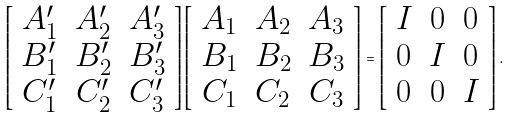<formula> <loc_0><loc_0><loc_500><loc_500>\left [ \begin{array} { c c c } A _ { 1 } ^ { \prime } & A _ { 2 } ^ { \prime } & A _ { 3 } ^ { \prime } \\ B _ { 1 } ^ { \prime } & B _ { 2 } ^ { \prime } & B _ { 3 } ^ { \prime } \\ C _ { 1 } ^ { \prime } & C _ { 2 } ^ { \prime } & C _ { 3 } ^ { \prime } \\ \end{array} \right ] \left [ \begin{array} { c c c } A _ { 1 } & A _ { 2 } & A _ { 3 } \\ B _ { 1 } & B _ { 2 } & B _ { 3 } \\ C _ { 1 } & C _ { 2 } & C _ { 3 } \\ \end{array} \right ] = \left [ \begin{array} { c c c } I & 0 & 0 \\ 0 & I & 0 \\ 0 & 0 & I \\ \end{array} \right ] .</formula> 